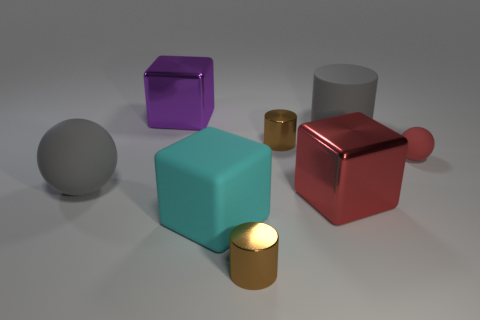Subtract all green cylinders. Subtract all blue spheres. How many cylinders are left? 3 Add 1 large purple rubber cubes. How many objects exist? 9 Subtract all cubes. How many objects are left? 5 Subtract all large cyan things. Subtract all matte cylinders. How many objects are left? 6 Add 6 big matte objects. How many big matte objects are left? 9 Add 4 gray rubber balls. How many gray rubber balls exist? 5 Subtract 0 gray cubes. How many objects are left? 8 